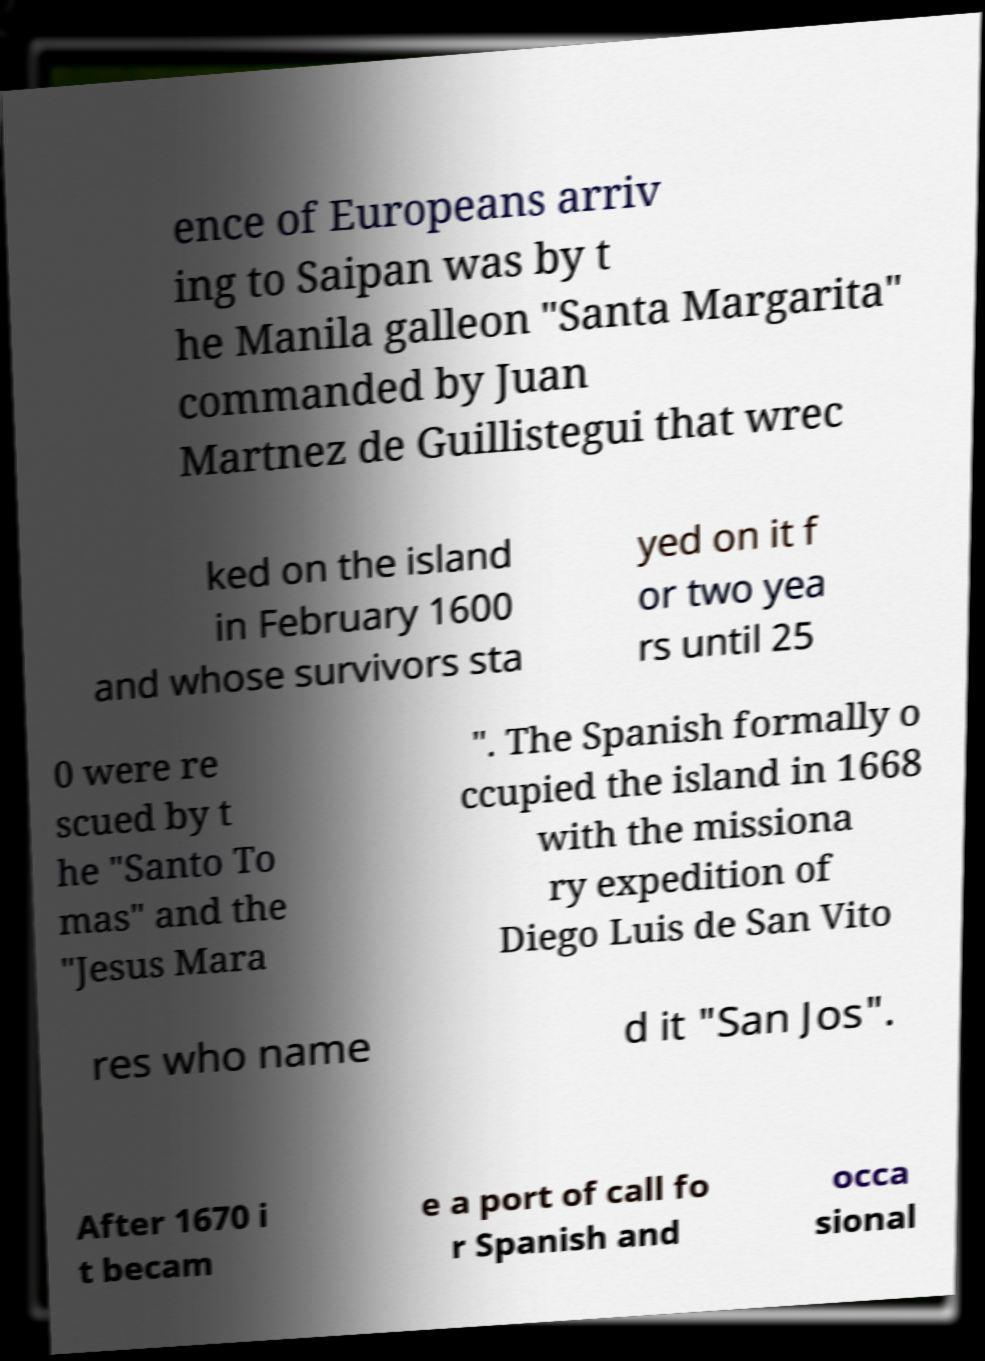Can you accurately transcribe the text from the provided image for me? ence of Europeans arriv ing to Saipan was by t he Manila galleon "Santa Margarita" commanded by Juan Martnez de Guillistegui that wrec ked on the island in February 1600 and whose survivors sta yed on it f or two yea rs until 25 0 were re scued by t he "Santo To mas" and the "Jesus Mara ". The Spanish formally o ccupied the island in 1668 with the missiona ry expedition of Diego Luis de San Vito res who name d it "San Jos". After 1670 i t becam e a port of call fo r Spanish and occa sional 